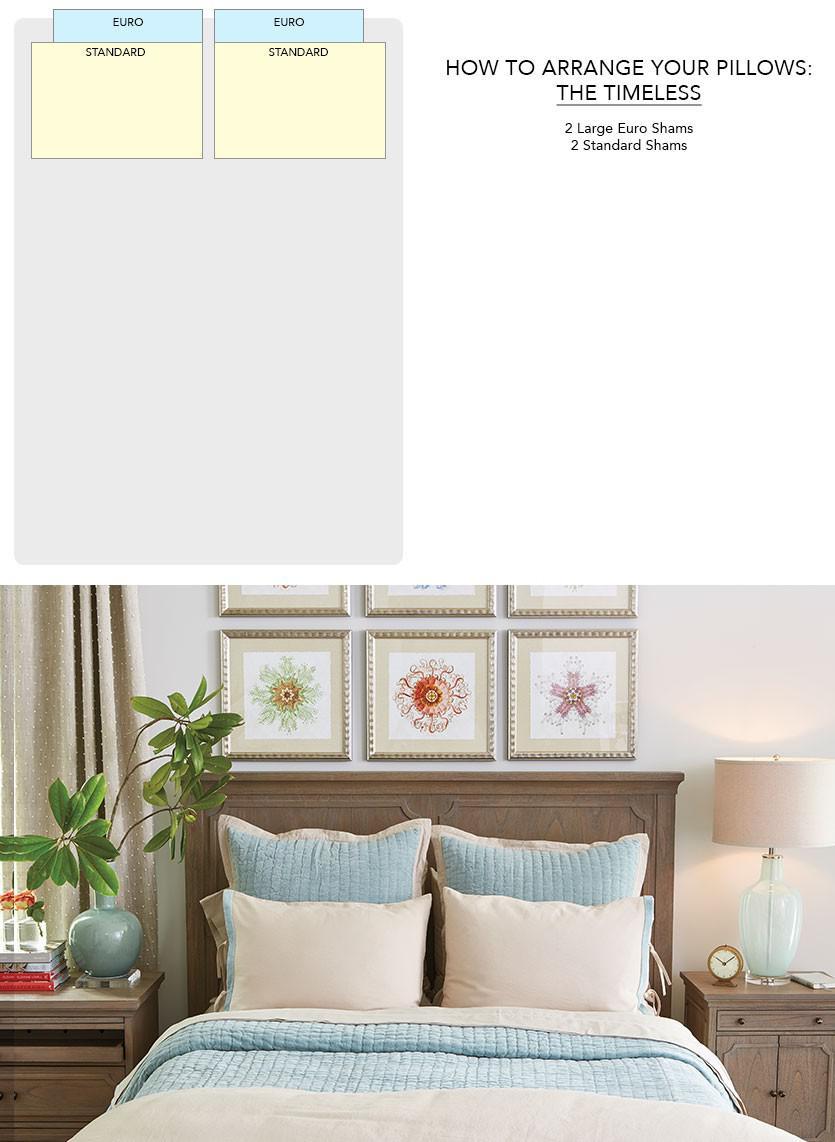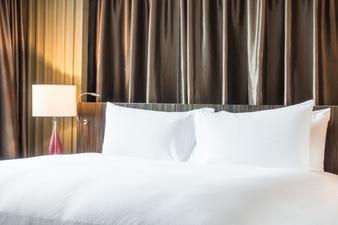The first image is the image on the left, the second image is the image on the right. Examine the images to the left and right. Is the description "there is white bedding on a bed with dark curtains behind the bed" accurate? Answer yes or no. Yes. The first image is the image on the left, the second image is the image on the right. Considering the images on both sides, is "One image shows a bed with all white bedding in front of a brown headboard and matching drape." valid? Answer yes or no. Yes. 